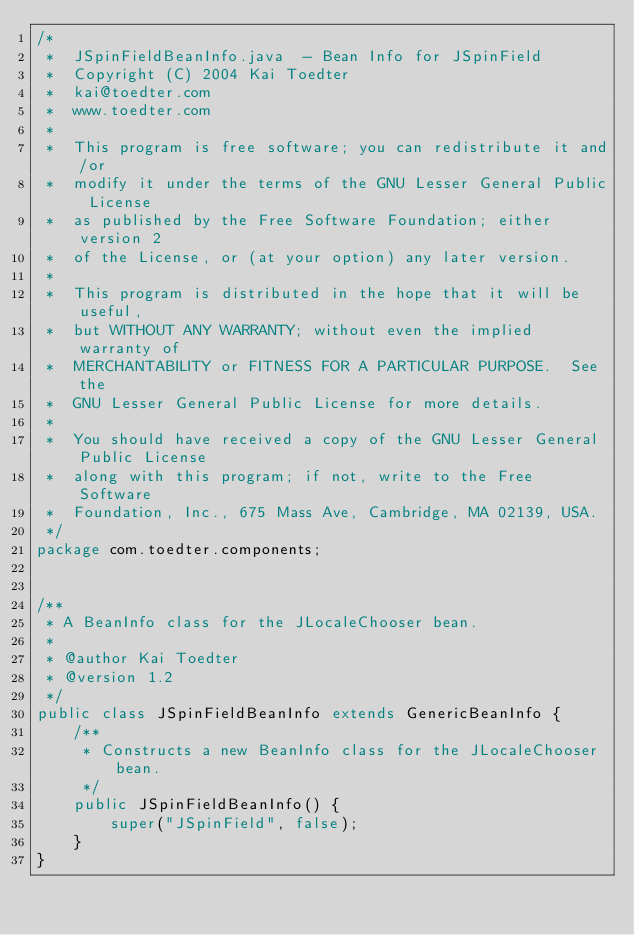<code> <loc_0><loc_0><loc_500><loc_500><_Java_>/*
 *  JSpinFieldBeanInfo.java  - Bean Info for JSpinField
 *  Copyright (C) 2004 Kai Toedter
 *  kai@toedter.com
 *  www.toedter.com
 *
 *  This program is free software; you can redistribute it and/or
 *  modify it under the terms of the GNU Lesser General Public License
 *  as published by the Free Software Foundation; either version 2
 *  of the License, or (at your option) any later version.
 *
 *  This program is distributed in the hope that it will be useful,
 *  but WITHOUT ANY WARRANTY; without even the implied warranty of
 *  MERCHANTABILITY or FITNESS FOR A PARTICULAR PURPOSE.  See the
 *  GNU Lesser General Public License for more details.
 *
 *  You should have received a copy of the GNU Lesser General Public License
 *  along with this program; if not, write to the Free Software
 *  Foundation, Inc., 675 Mass Ave, Cambridge, MA 02139, USA.
 */
package com.toedter.components;


/**
 * A BeanInfo class for the JLocaleChooser bean.
 *
 * @author Kai Toedter
 * @version 1.2
 */
public class JSpinFieldBeanInfo extends GenericBeanInfo {
    /**
     * Constructs a new BeanInfo class for the JLocaleChooser bean.
     */
    public JSpinFieldBeanInfo() {
        super("JSpinField", false);
    }
}</code> 